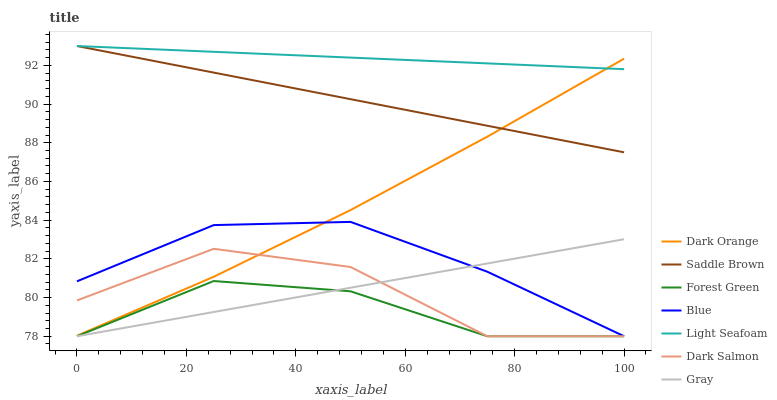Does Forest Green have the minimum area under the curve?
Answer yes or no. Yes. Does Light Seafoam have the maximum area under the curve?
Answer yes or no. Yes. Does Dark Orange have the minimum area under the curve?
Answer yes or no. No. Does Dark Orange have the maximum area under the curve?
Answer yes or no. No. Is Gray the smoothest?
Answer yes or no. Yes. Is Dark Salmon the roughest?
Answer yes or no. Yes. Is Dark Orange the smoothest?
Answer yes or no. No. Is Dark Orange the roughest?
Answer yes or no. No. Does Blue have the lowest value?
Answer yes or no. Yes. Does Dark Orange have the lowest value?
Answer yes or no. No. Does Saddle Brown have the highest value?
Answer yes or no. Yes. Does Dark Orange have the highest value?
Answer yes or no. No. Is Gray less than Dark Orange?
Answer yes or no. Yes. Is Dark Orange greater than Forest Green?
Answer yes or no. Yes. Does Blue intersect Dark Orange?
Answer yes or no. Yes. Is Blue less than Dark Orange?
Answer yes or no. No. Is Blue greater than Dark Orange?
Answer yes or no. No. Does Gray intersect Dark Orange?
Answer yes or no. No. 